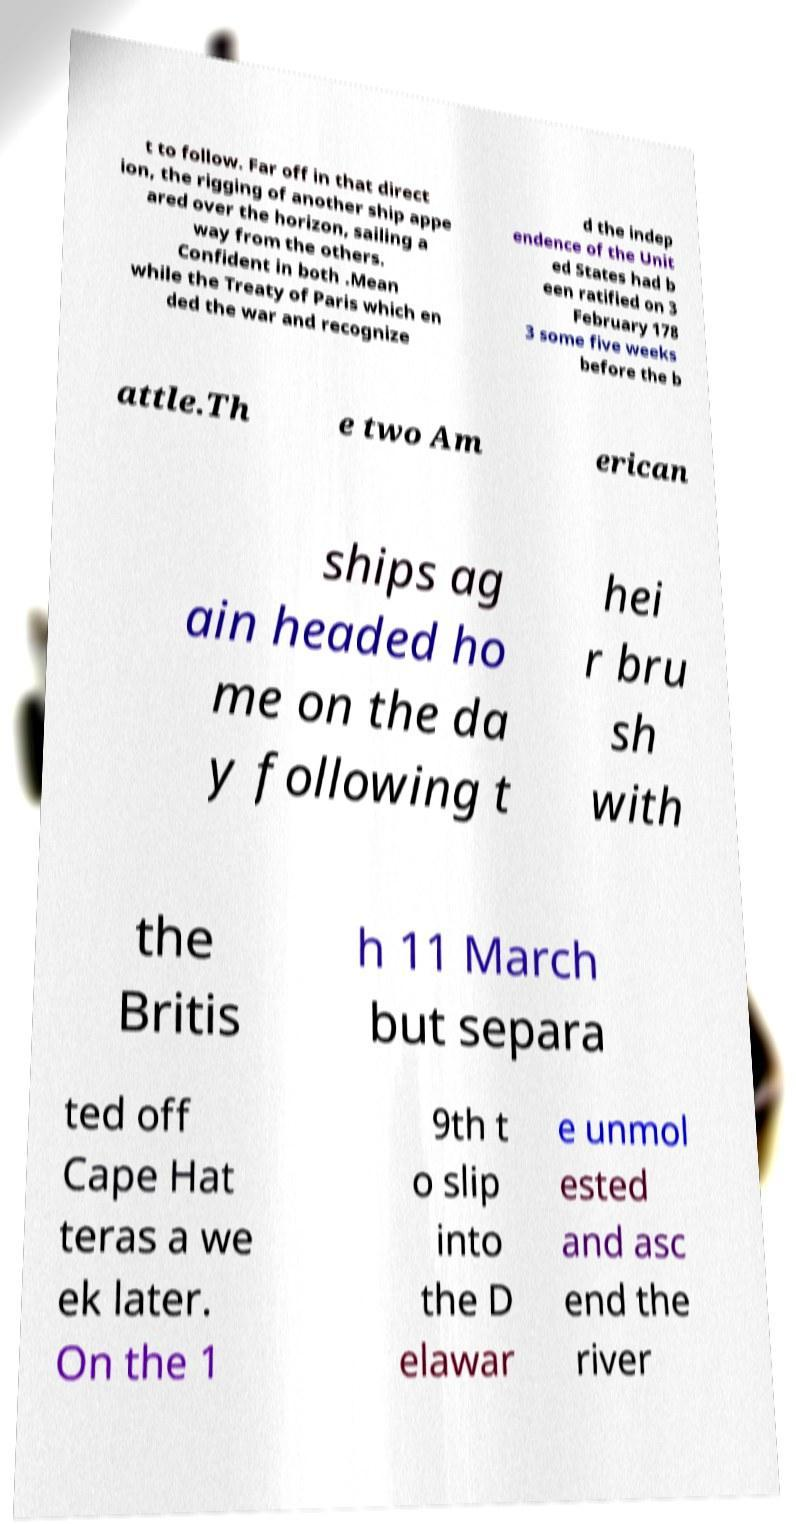For documentation purposes, I need the text within this image transcribed. Could you provide that? t to follow. Far off in that direct ion, the rigging of another ship appe ared over the horizon, sailing a way from the others. Confident in both .Mean while the Treaty of Paris which en ded the war and recognize d the indep endence of the Unit ed States had b een ratified on 3 February 178 3 some five weeks before the b attle.Th e two Am erican ships ag ain headed ho me on the da y following t hei r bru sh with the Britis h 11 March but separa ted off Cape Hat teras a we ek later. On the 1 9th t o slip into the D elawar e unmol ested and asc end the river 